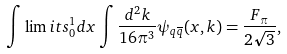Convert formula to latex. <formula><loc_0><loc_0><loc_500><loc_500>\int \lim i t s _ { 0 } ^ { 1 } d x \int \frac { d ^ { 2 } k } { 1 6 \pi ^ { 3 } } \psi _ { q \overline { q } } ( x , k ) = \frac { F _ { \pi } } { 2 \sqrt { 3 } } ,</formula> 